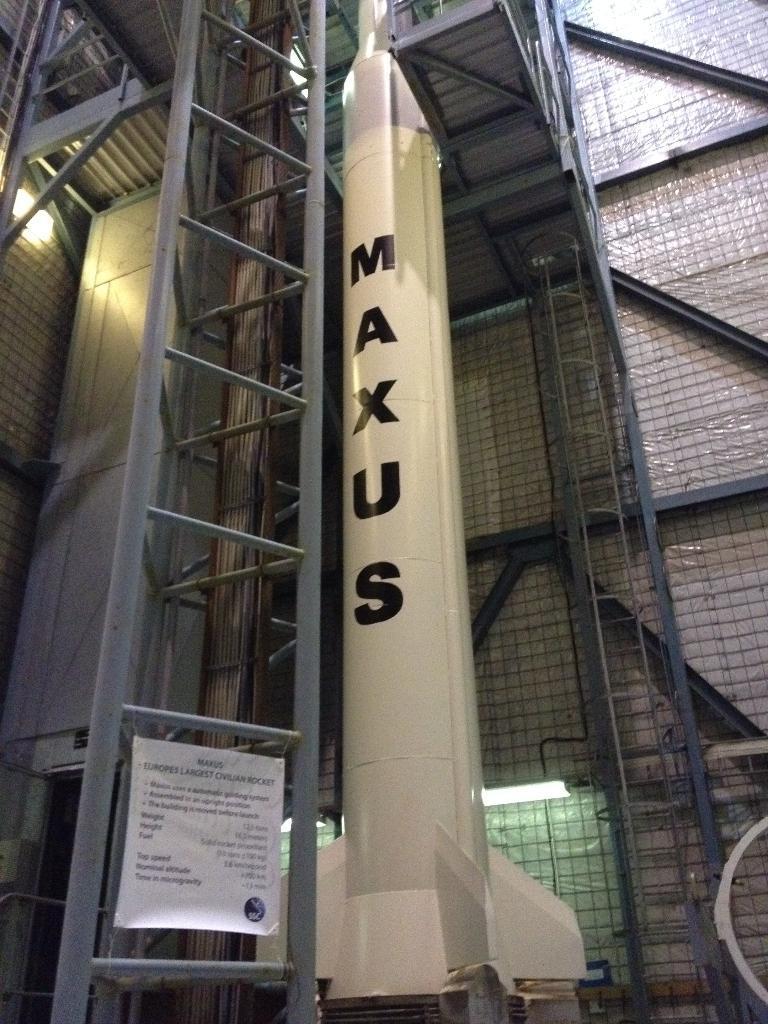Can you describe this image briefly? This looks like a rocket. I think this picture was taken inside the building. This looks like a kind of a ladder. I can see banner, which is tied to the ladder. 